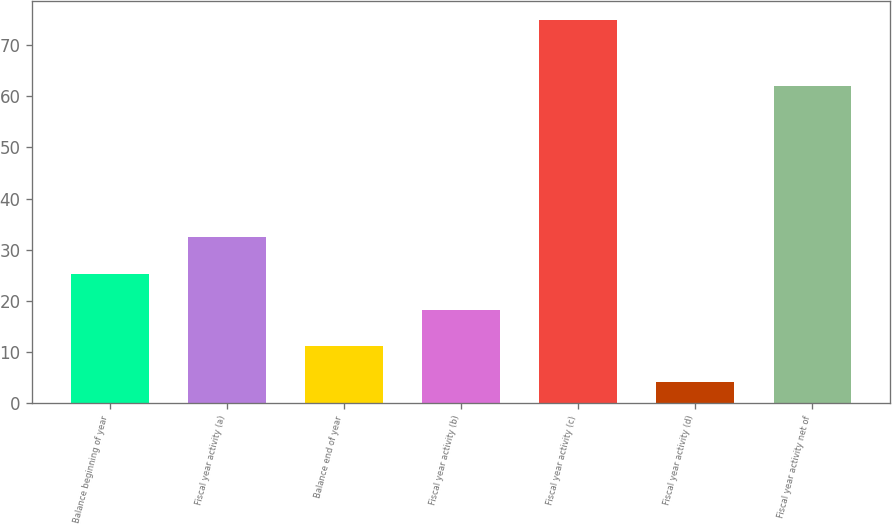<chart> <loc_0><loc_0><loc_500><loc_500><bar_chart><fcel>Balance beginning of year<fcel>Fiscal year activity (a)<fcel>Balance end of year<fcel>Fiscal year activity (b)<fcel>Fiscal year activity (c)<fcel>Fiscal year activity (d)<fcel>Fiscal year activity net of<nl><fcel>25.3<fcel>32.4<fcel>11.1<fcel>18.2<fcel>75<fcel>4<fcel>62<nl></chart> 